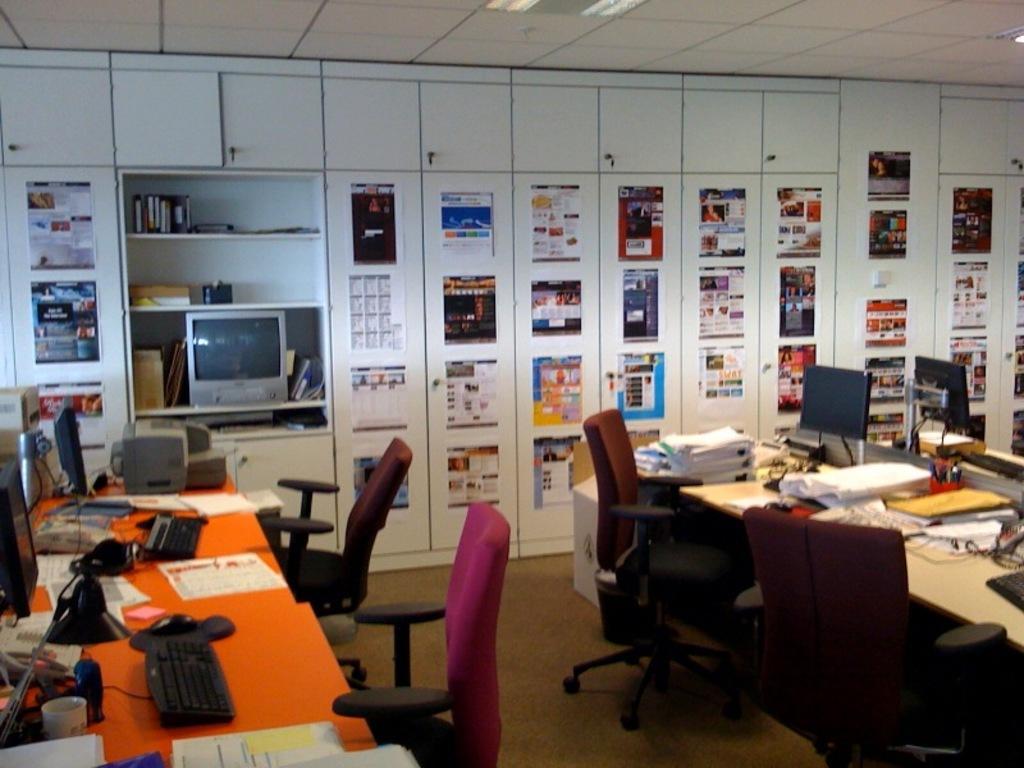In one or two sentences, can you explain what this image depicts? As we can see in the image there are cupboards, posters, television, laptops, keyboards, mouses, tables, chairs, books and papers. 